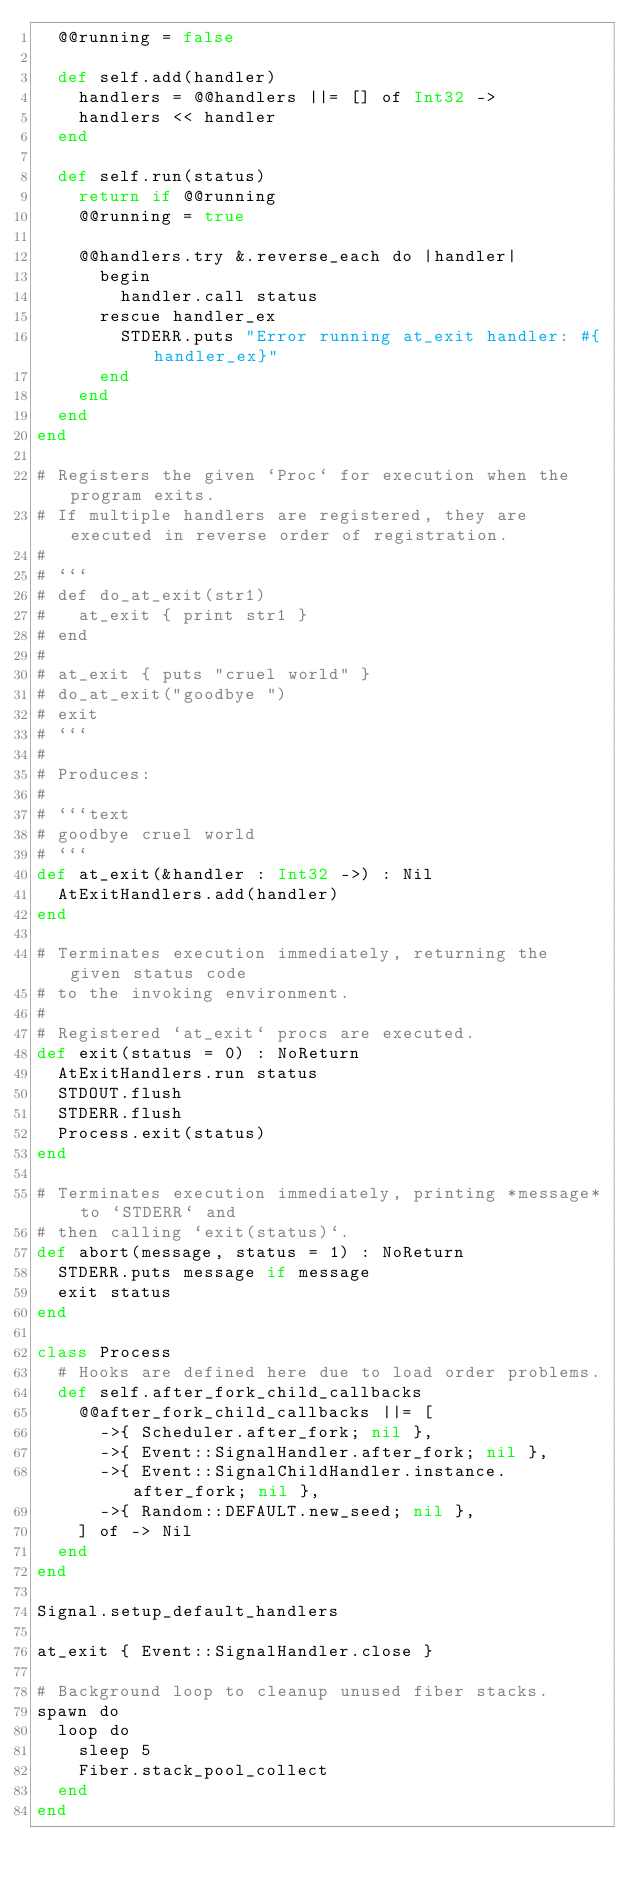Convert code to text. <code><loc_0><loc_0><loc_500><loc_500><_Crystal_>  @@running = false

  def self.add(handler)
    handlers = @@handlers ||= [] of Int32 ->
    handlers << handler
  end

  def self.run(status)
    return if @@running
    @@running = true

    @@handlers.try &.reverse_each do |handler|
      begin
        handler.call status
      rescue handler_ex
        STDERR.puts "Error running at_exit handler: #{handler_ex}"
      end
    end
  end
end

# Registers the given `Proc` for execution when the program exits.
# If multiple handlers are registered, they are executed in reverse order of registration.
#
# ```
# def do_at_exit(str1)
#   at_exit { print str1 }
# end
#
# at_exit { puts "cruel world" }
# do_at_exit("goodbye ")
# exit
# ```
#
# Produces:
#
# ```text
# goodbye cruel world
# ```
def at_exit(&handler : Int32 ->) : Nil
  AtExitHandlers.add(handler)
end

# Terminates execution immediately, returning the given status code
# to the invoking environment.
#
# Registered `at_exit` procs are executed.
def exit(status = 0) : NoReturn
  AtExitHandlers.run status
  STDOUT.flush
  STDERR.flush
  Process.exit(status)
end

# Terminates execution immediately, printing *message* to `STDERR` and
# then calling `exit(status)`.
def abort(message, status = 1) : NoReturn
  STDERR.puts message if message
  exit status
end

class Process
  # Hooks are defined here due to load order problems.
  def self.after_fork_child_callbacks
    @@after_fork_child_callbacks ||= [
      ->{ Scheduler.after_fork; nil },
      ->{ Event::SignalHandler.after_fork; nil },
      ->{ Event::SignalChildHandler.instance.after_fork; nil },
      ->{ Random::DEFAULT.new_seed; nil },
    ] of -> Nil
  end
end

Signal.setup_default_handlers

at_exit { Event::SignalHandler.close }

# Background loop to cleanup unused fiber stacks.
spawn do
  loop do
    sleep 5
    Fiber.stack_pool_collect
  end
end
</code> 